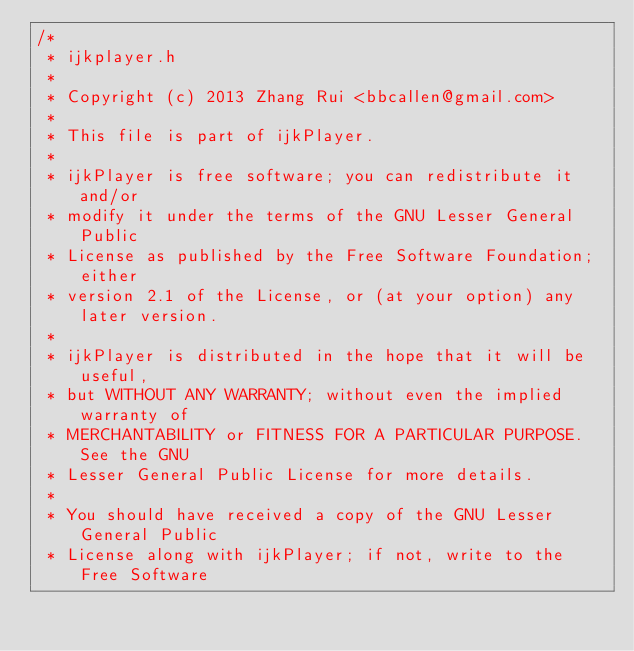Convert code to text. <code><loc_0><loc_0><loc_500><loc_500><_C_>/*
 * ijkplayer.h
 *
 * Copyright (c) 2013 Zhang Rui <bbcallen@gmail.com>
 *
 * This file is part of ijkPlayer.
 *
 * ijkPlayer is free software; you can redistribute it and/or
 * modify it under the terms of the GNU Lesser General Public
 * License as published by the Free Software Foundation; either
 * version 2.1 of the License, or (at your option) any later version.
 *
 * ijkPlayer is distributed in the hope that it will be useful,
 * but WITHOUT ANY WARRANTY; without even the implied warranty of
 * MERCHANTABILITY or FITNESS FOR A PARTICULAR PURPOSE.  See the GNU
 * Lesser General Public License for more details.
 *
 * You should have received a copy of the GNU Lesser General Public
 * License along with ijkPlayer; if not, write to the Free Software</code> 